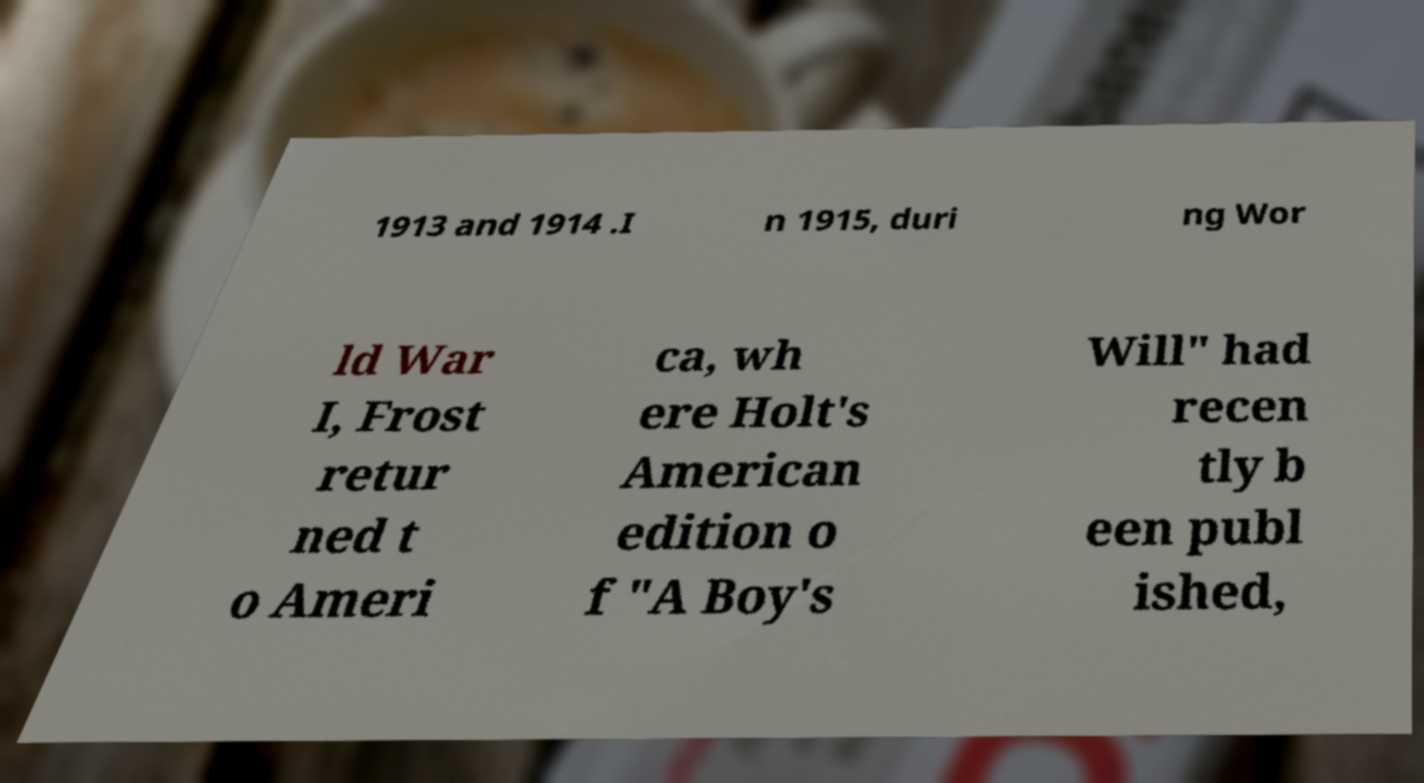Please read and relay the text visible in this image. What does it say? 1913 and 1914 .I n 1915, duri ng Wor ld War I, Frost retur ned t o Ameri ca, wh ere Holt's American edition o f "A Boy's Will" had recen tly b een publ ished, 